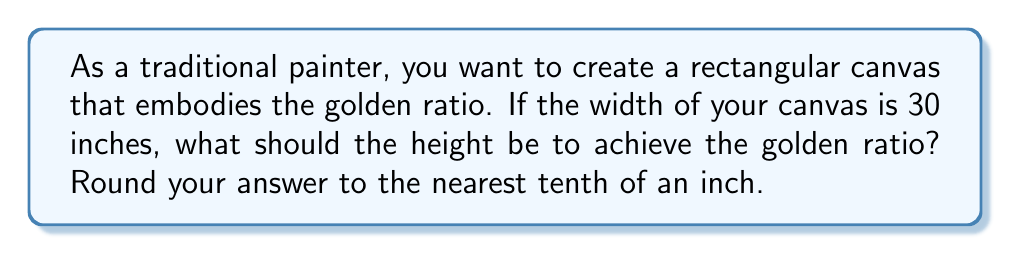Give your solution to this math problem. The golden ratio, denoted by the Greek letter φ (phi), is approximately 1.618033988749895. In a rectangle, the golden ratio is achieved when the ratio of the longer side to the shorter side is equal to φ.

Let's approach this step-by-step:

1) We know the width of the canvas is 30 inches. Let's call the height $h$ inches.

2) The golden ratio formula for a rectangle is:
   
   $$\frac{\text{longer side}}{\text{shorter side}} = \phi$$

3) In this case, the height will be the longer side, so we can write:

   $$\frac{h}{30} = \phi$$

4) We can solve this equation for $h$:

   $$h = 30 \cdot \phi$$

5) Now, let's substitute the value of φ:

   $$h = 30 \cdot 1.618033988749895$$

6) Calculating this:

   $$h = 48.54101966249685$$

7) Rounding to the nearest tenth of an inch:

   $$h \approx 48.5 \text{ inches}$$

[asy]
size(200);
pen canvasColor = rgb(0.95,0.95,0.9);
pen borderColor = rgb(0.6,0.4,0.2);
fill(box((0,0),(30,48.5)), canvasColor);
draw(box((0,0),(30,48.5)), borderColor+1);
label("30\"", (15,0), S);
label("48.5\"", (30,24.25), E);
[/asy]

This diagram illustrates the proportions of the golden ratio canvas.
Answer: The height of the canvas should be 48.5 inches. 